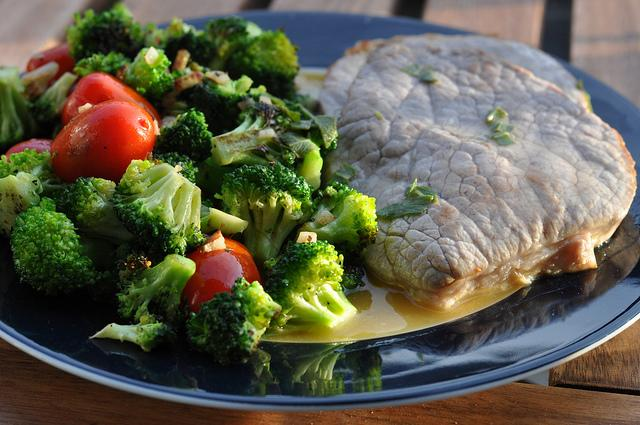What variety of tomato is on the plate?

Choices:
A) hot house
B) heirloom
C) roma
D) cherry cherry 